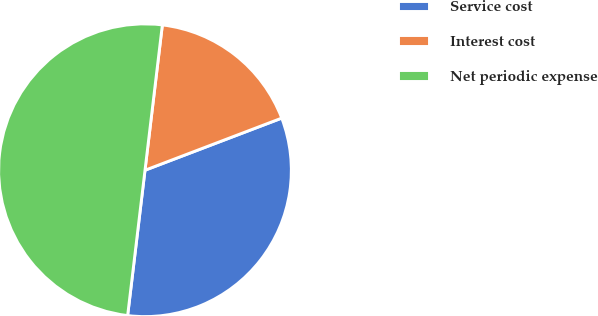<chart> <loc_0><loc_0><loc_500><loc_500><pie_chart><fcel>Service cost<fcel>Interest cost<fcel>Net periodic expense<nl><fcel>32.69%<fcel>17.31%<fcel>50.0%<nl></chart> 